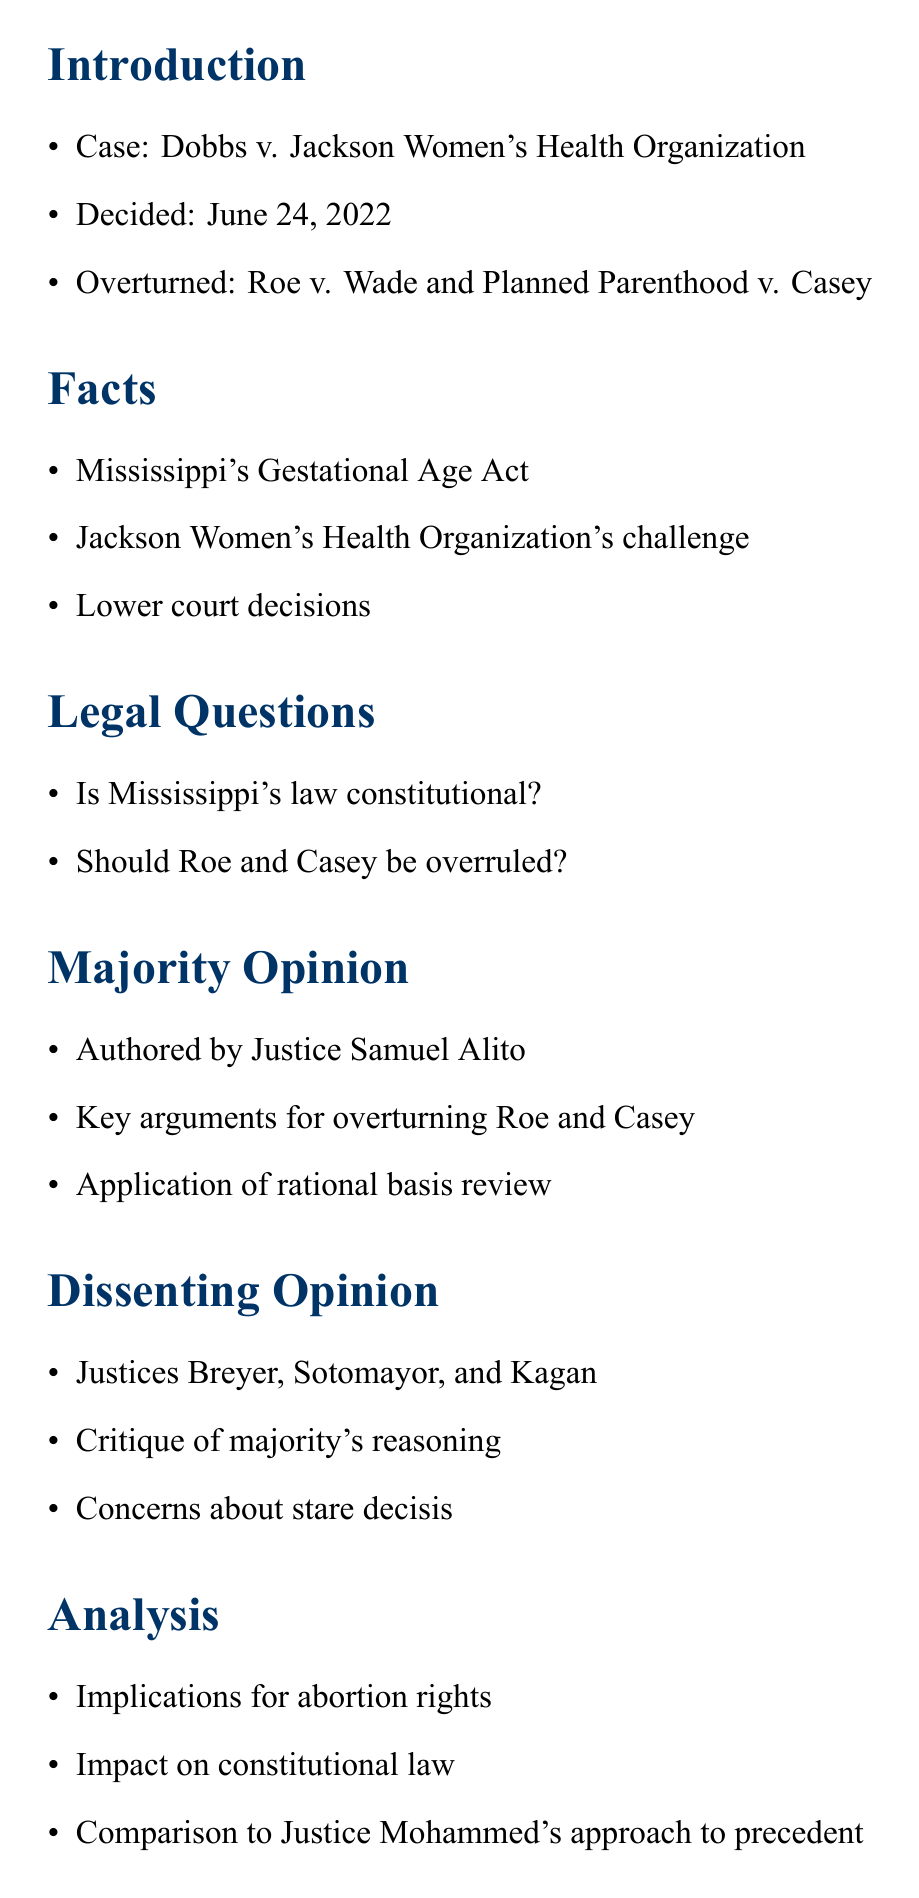What is the case name? The document provides the full name of the case in the introduction section.
Answer: Dobbs v. Jackson Women's Health Organization When was the decision made? The decision date is mentioned in the introduction section of the document.
Answer: June 24, 2022 Who authored the majority opinion? Details about the majority opinion, including the author, are found in the related section.
Answer: Justice Samuel Alito What is the main legal question regarding Mississippi's law? The legal questions are listed in their respective section, focusing on the law's constitutionality.
Answer: Is Mississippi's law constitutional? Which justices dissented in the ruling? The dissenting opinions section states the names of the dissenting justices.
Answer: Breyer, Sotomayor, and Kagan What is mentioned about Justice Mohammed in the analysis? The analysis contains a comparison to Justice Mohammed's approach to precedent.
Answer: Comparison to Justice Mohammed's approach to precedent What significant legal precedents were overturned? The case names overturned by the decision are listed in the introduction section.
Answer: Roe v. Wade and Planned Parenthood v. Casey What is discussed in the conclusion? The conclusion summarizes key points and includes personal reflection as a law student.
Answer: Summary of key points What impact does the decision have according to the analysis? The analysis section discusses implications for abortion rights and constitutional law.
Answer: Implications for abortion rights 